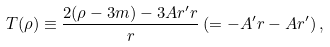<formula> <loc_0><loc_0><loc_500><loc_500>T ( \rho ) \equiv \frac { 2 ( \rho - 3 m ) - 3 A r ^ { \prime } r } { r } \, ( = - A ^ { \prime } r - A r ^ { \prime } ) \, ,</formula> 